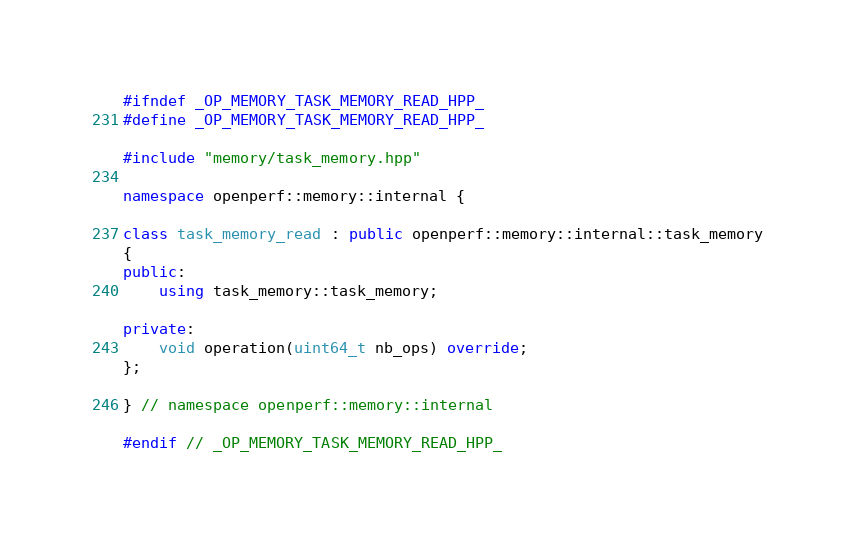Convert code to text. <code><loc_0><loc_0><loc_500><loc_500><_C++_>#ifndef _OP_MEMORY_TASK_MEMORY_READ_HPP_
#define _OP_MEMORY_TASK_MEMORY_READ_HPP_

#include "memory/task_memory.hpp"

namespace openperf::memory::internal {

class task_memory_read : public openperf::memory::internal::task_memory
{
public:
    using task_memory::task_memory;

private:
    void operation(uint64_t nb_ops) override;
};

} // namespace openperf::memory::internal

#endif // _OP_MEMORY_TASK_MEMORY_READ_HPP_
</code> 